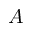Convert formula to latex. <formula><loc_0><loc_0><loc_500><loc_500>A</formula> 